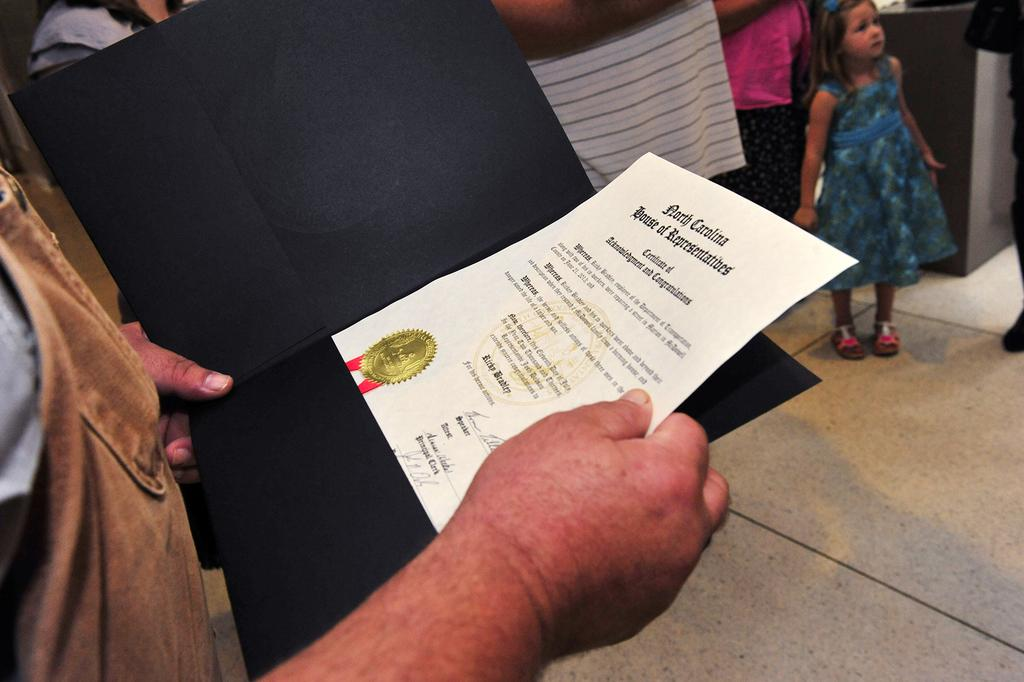What is the person in the image holding? The person is holding a paper and a file in the image. What is the kid doing in the image? The kid is standing on the floor in the image. What can be seen in the background of the image? There is a wall visible in the background of the image. Can you describe the people in the background? The people in the background are truncated, so we cannot see their full bodies. What type of plant is the cat watering in the image? There is no cat or plant present in the image. 